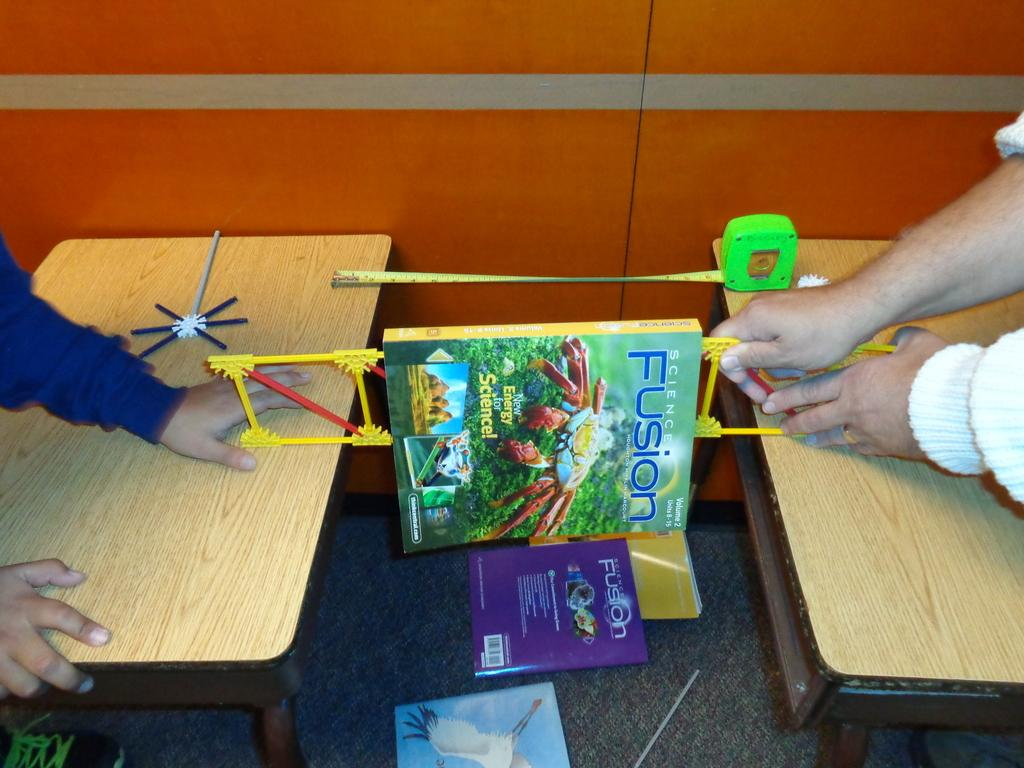<image>
Provide a brief description of the given image. Two people suspend a science book titled Fusion between two desks. 